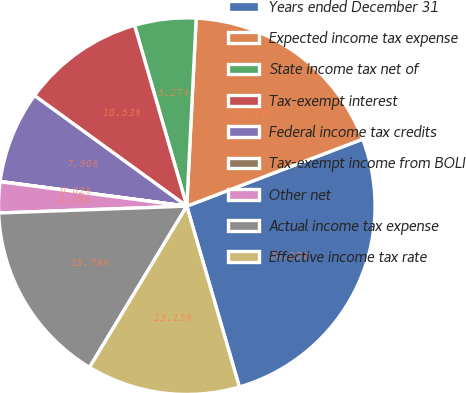<chart> <loc_0><loc_0><loc_500><loc_500><pie_chart><fcel>Years ended December 31<fcel>Expected income tax expense<fcel>State income tax net of<fcel>Tax-exempt interest<fcel>Federal income tax credits<fcel>Tax-exempt income from BOLI<fcel>Other net<fcel>Actual income tax expense<fcel>Effective income tax rate<nl><fcel>26.29%<fcel>18.41%<fcel>5.27%<fcel>10.53%<fcel>7.9%<fcel>0.02%<fcel>2.65%<fcel>15.78%<fcel>13.15%<nl></chart> 